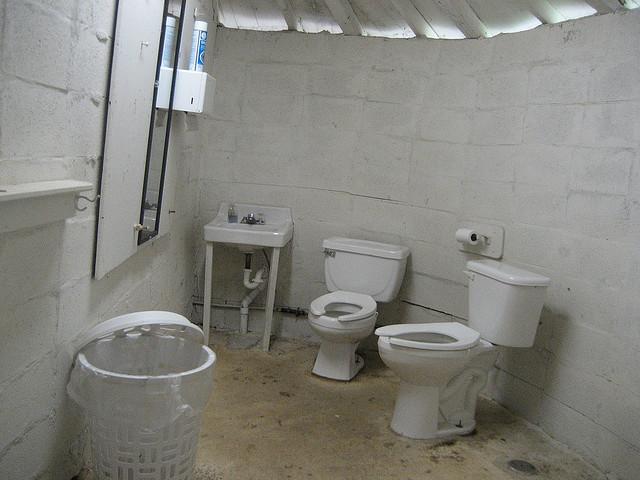Is the floor clean?
Be succinct. No. What are the walls and floor made out of?
Write a very short answer. Concrete. How many toilet seats are there?
Quick response, please. 2. What kind of room is this?
Quick response, please. Bathroom. What installment is next to the toilet?
Answer briefly. Sink. 